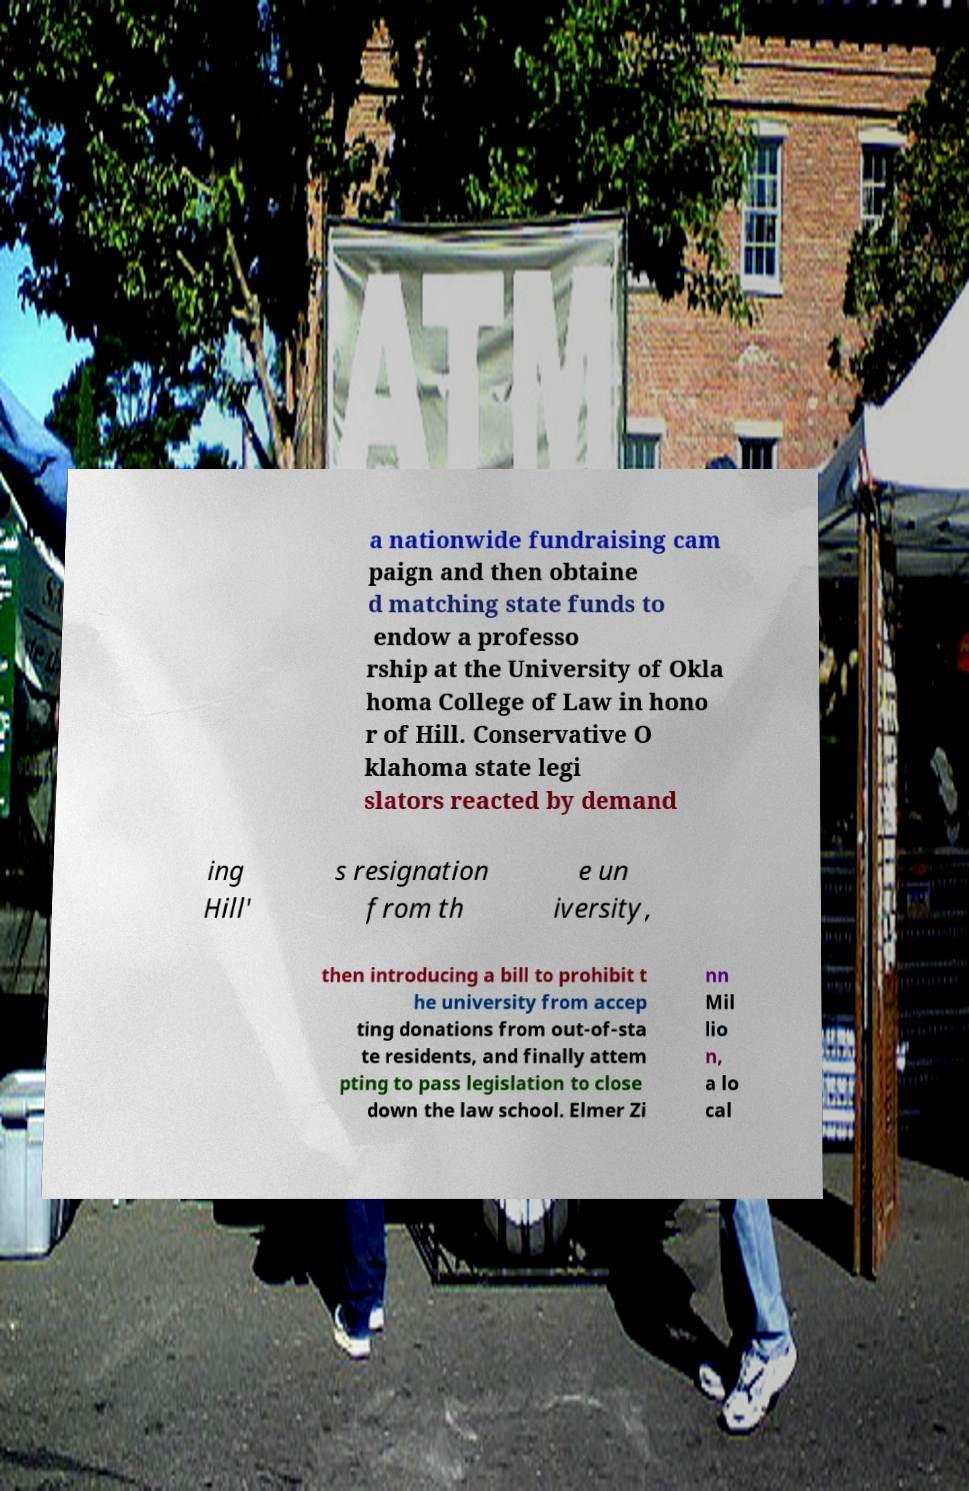Please identify and transcribe the text found in this image. a nationwide fundraising cam paign and then obtaine d matching state funds to endow a professo rship at the University of Okla homa College of Law in hono r of Hill. Conservative O klahoma state legi slators reacted by demand ing Hill' s resignation from th e un iversity, then introducing a bill to prohibit t he university from accep ting donations from out-of-sta te residents, and finally attem pting to pass legislation to close down the law school. Elmer Zi nn Mil lio n, a lo cal 